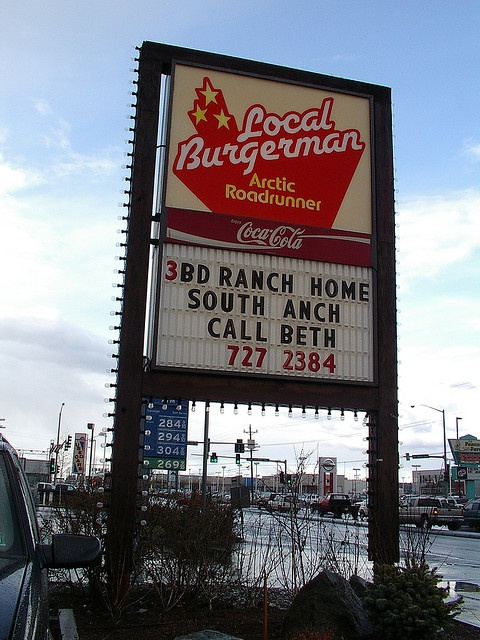Describe the objects in this image and their specific colors. I can see car in lavender, black, gray, blue, and navy tones, truck in lavender, black, gray, darkgray, and purple tones, truck in lavender, black, gray, maroon, and darkgray tones, car in lavender, black, gray, and blue tones, and car in lavender, black, gray, and maroon tones in this image. 